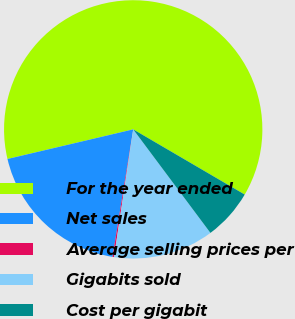Convert chart to OTSL. <chart><loc_0><loc_0><loc_500><loc_500><pie_chart><fcel>For the year ended<fcel>Net sales<fcel>Average selling prices per<fcel>Gigabits sold<fcel>Cost per gigabit<nl><fcel>62.11%<fcel>18.76%<fcel>0.19%<fcel>12.57%<fcel>6.38%<nl></chart> 